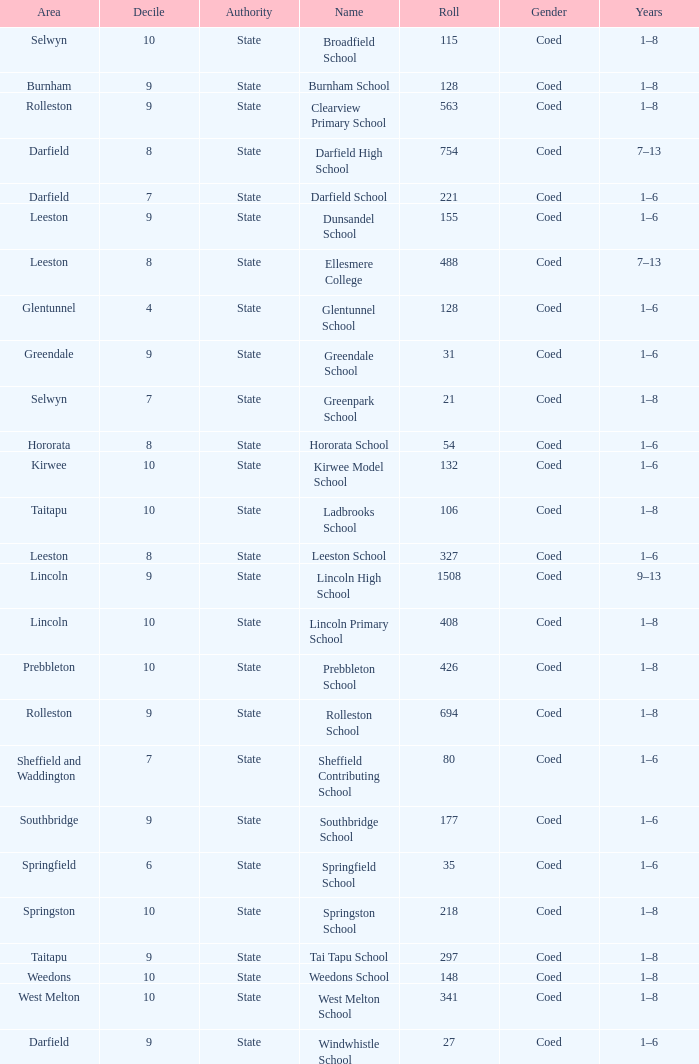What is the name with a Decile less than 10, and a Roll of 297? Tai Tapu School. 